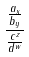Convert formula to latex. <formula><loc_0><loc_0><loc_500><loc_500>\frac { \frac { a _ { x } } { b _ { y } } } { \frac { c ^ { z } } { d ^ { w } } }</formula> 